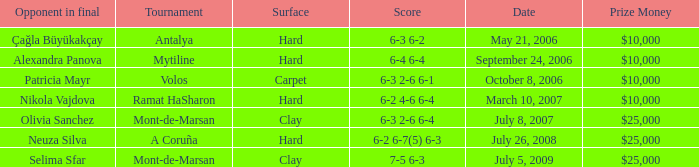What is the score of the hard court Ramat Hasharon tournament? 6-2 4-6 6-4. 